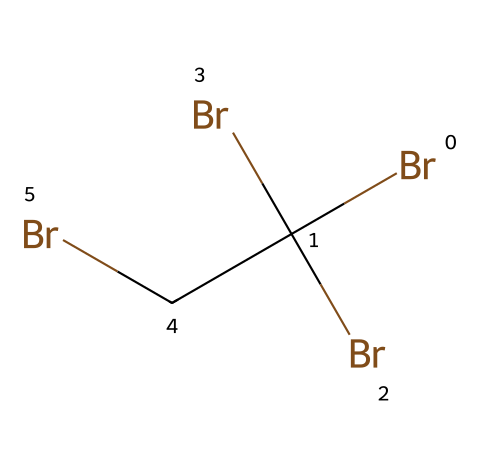What is the total number of bromine atoms in the structure? The SMILES representation indicates that there are four 'Br' notations, each representing a bromine atom. Thus, by counting these 'Br' notations in the chemical structure, we find that there are four bromine atoms present.
Answer: four What is the central atom in this chemical structure? In the provided SMILES, the central atom is represented by the first 'C' notation before the bromine atoms, indicating that carbon is the central atom bonded to multiple bromine atoms.
Answer: carbon How many carbon atoms are present in the molecule? The structure includes one 'C' at the beginning and another 'C' after the parentheses, which together indicates that there are two carbon atoms in total.
Answer: two Which chemical type does this chemical belong to? This chemical belongs to the halogenated hydrocarbons category due to the presence of both carbon and bromine atoms, where bromine represents the halogen. It exhibits properties typical of flame retardants.
Answer: halogenated hydrocarbon What is the molecular configuration about the central carbon atom? The central carbon atom is bonded to three bromine atoms and one additional carbon atom, indicating a tetrahedral molecular configuration typical for carbon covalent bonding.
Answer: tetrahedral How does the presence of bromine affect the compound's properties? Bromine atoms contribute to the compound's flame retardant properties by disrupting the combustion process, usually leading to lower flammability. Their presence often results in increased stability in electronic components.
Answer: flame retardant What role does bromine play in the context of electronic components? Bromine serves as a flame retardant in electronic components, reducing the risk of fire hazards by inhibiting combustion within the materials used. This halogen often enhances safety in electrical devices.
Answer: safety 